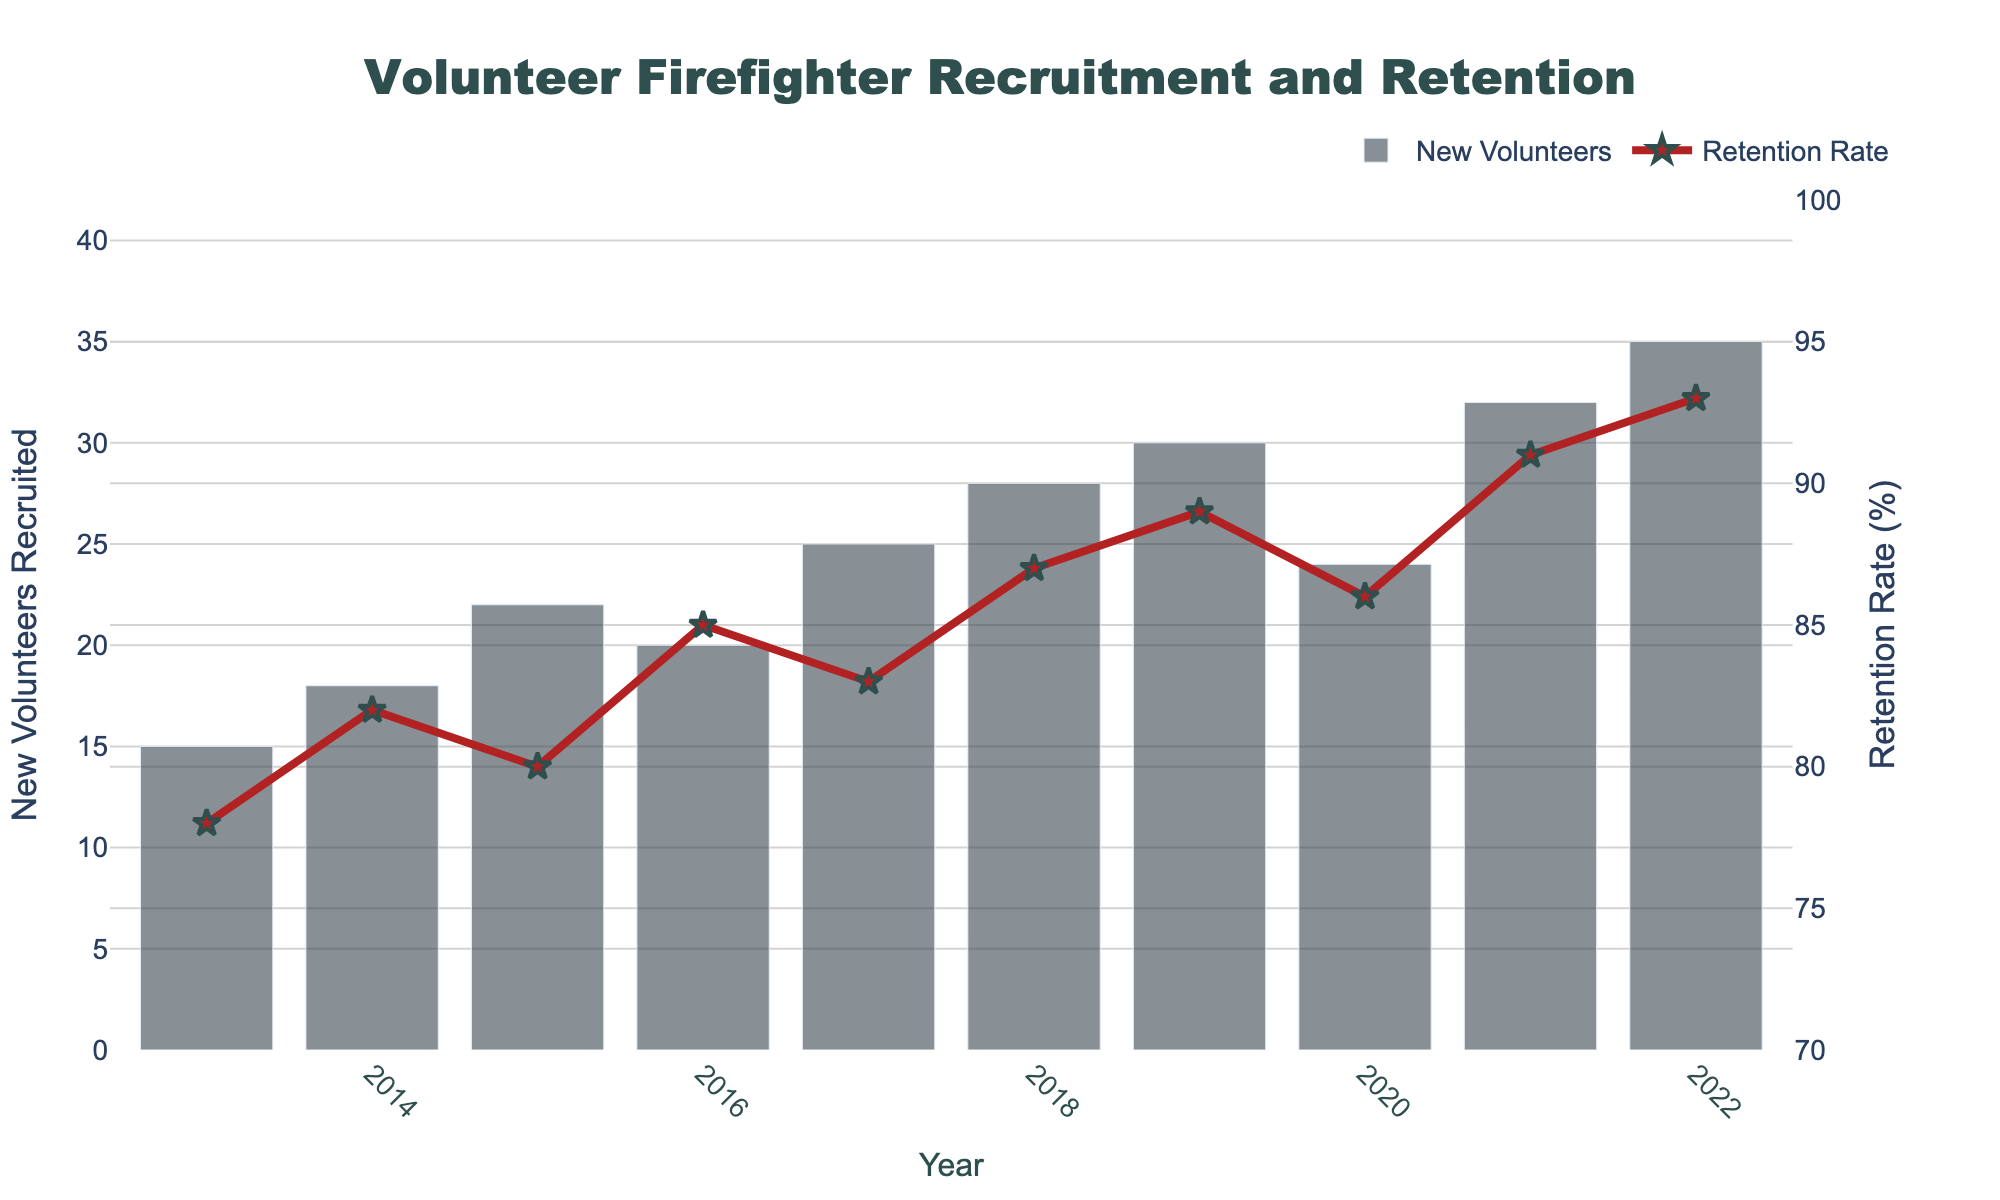How many new volunteers were recruited in 2019? Look at the bar corresponding to the year 2019. The height of the bar indicates 30 new volunteers recruited.
Answer: 30 What is the overall trend in the retention rate over the decade? Observe the line linking the markers from 2013 to 2022. The line consistently trends upwards, indicating an increase in the retention rate over the years.
Answer: Increasing Did the year with the highest number of recruits also have the highest retention rate? Identify the year with the highest bar (2022) and the year with the highest retention rate (also 2022). Both metrics peak in the same year, 2022.
Answer: Yes By how many new volunteers did the number recruited in 2022 exceed that in 2013? Subtract the number of new volunteers recruited in 2013 (15) from that in 2022 (35). The difference is 35 - 15 = 20.
Answer: 20 Is the retention rate in 2022 more than 10% higher compared to 2013? Compare the retention rates of 2022 (93%) and 2013 (78%). The increase is 93 - 78 = 15%, which is more than 10%.
Answer: Yes What can you say about the visual differences between the bars and the line plot? The bars are used to represent the number of new volunteers and are taller in later years, while the line plot represents the retention rate and trends upwards with markers at each year.
Answer: Bars are for volunteers, line is for retention Which year had the lowest retention rate? Identify the year where the lowest point of the line plot occurs. The lowest retention rate is in 2013, at 78%.
Answer: 2013 How much did the retention rate change from 2020 to 2021? Determine the retention rates for 2020 (86%) and 2021 (91%). The change is 91 - 86 = 5%.
Answer: 5% What is the average number of new volunteers recruited per year over the decade? Calculate the average by summing the new recruits and dividing by the number of years: (15 + 18 + 22 + 20 + 25 + 28 + 30 + 24 + 32 + 35) / 10 = 249 / 10 = 24.9.
Answer: 24.9 By how much did the number of new volunteers increase from 2019 to 2020, and what can be inferred from this change? The number of new volunteers decreased from 30 in 2019 to 24 in 2020. The decrease is 30 - 24 = 6, indicating a drop in new recruitments during this period.
Answer: Decreased by 6 